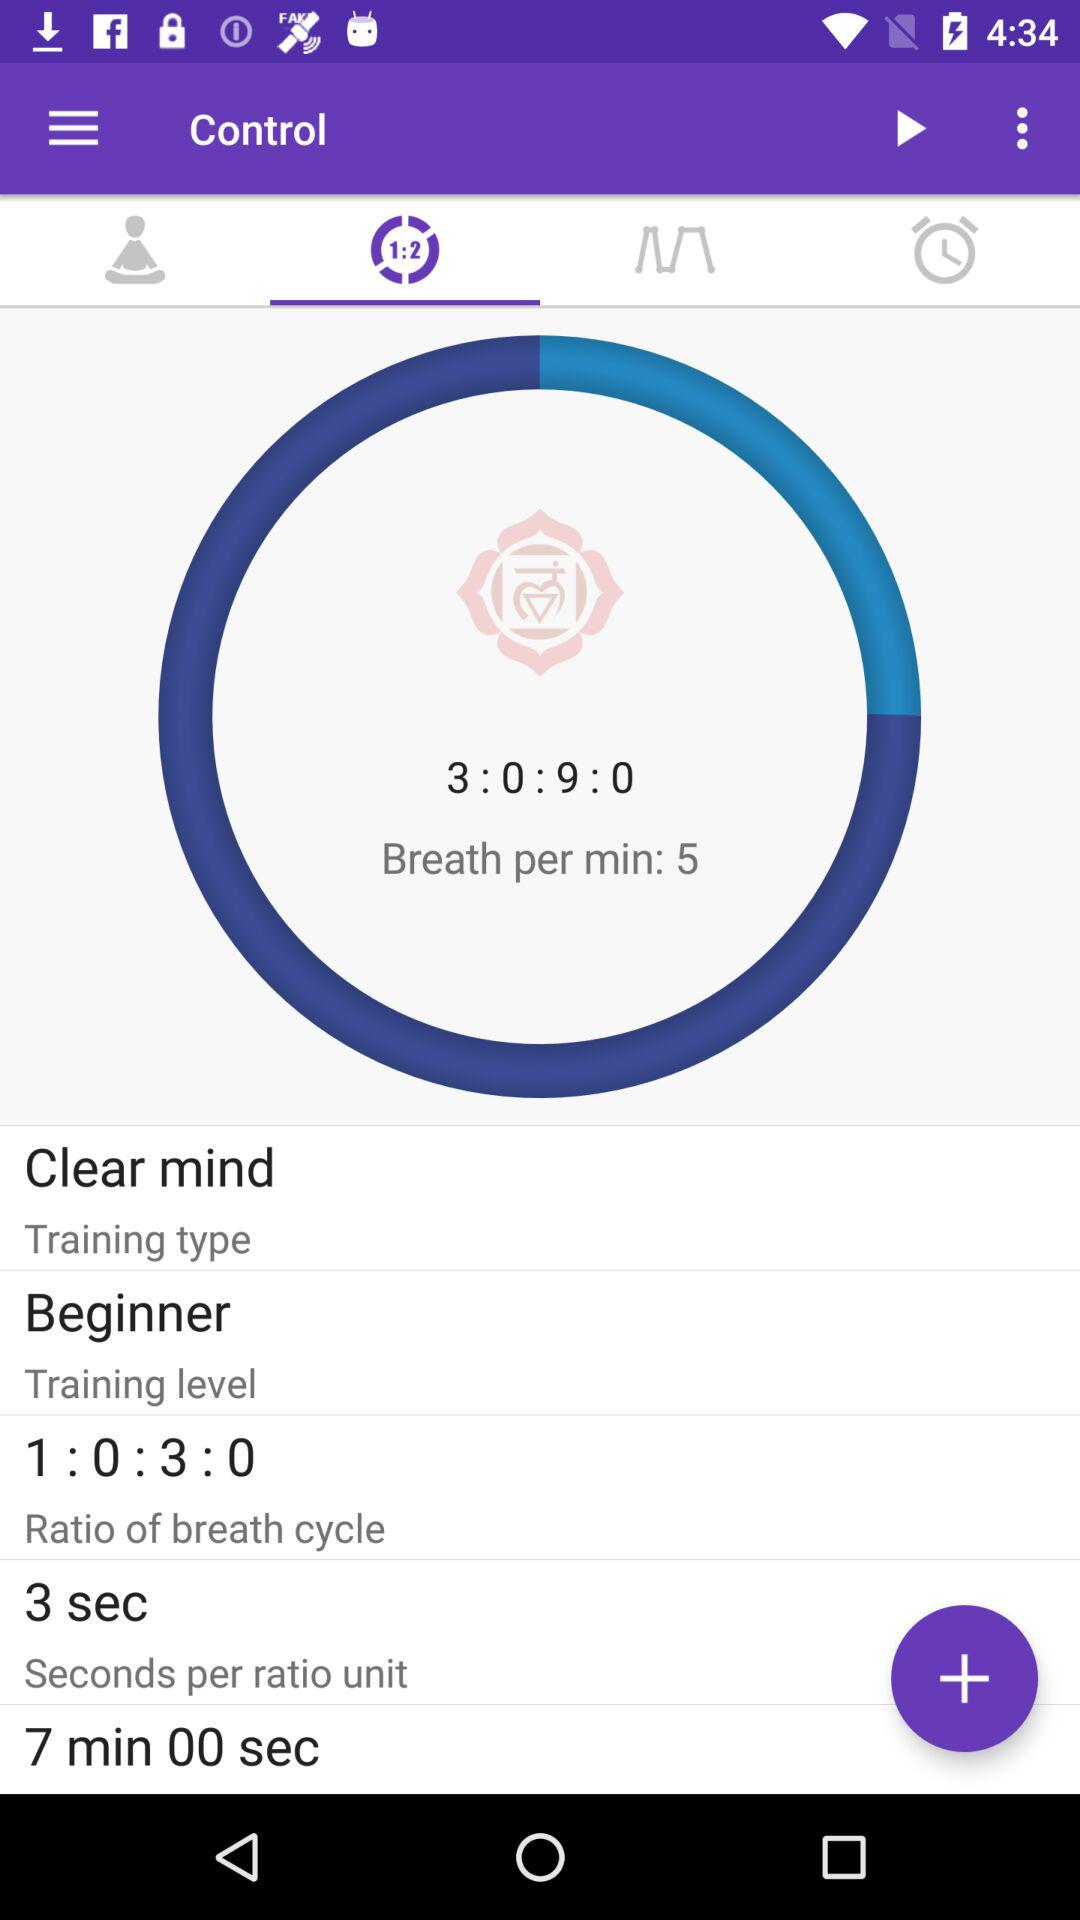What is the ratio of the breath cycle? The ratio is 1:0:3:0. 